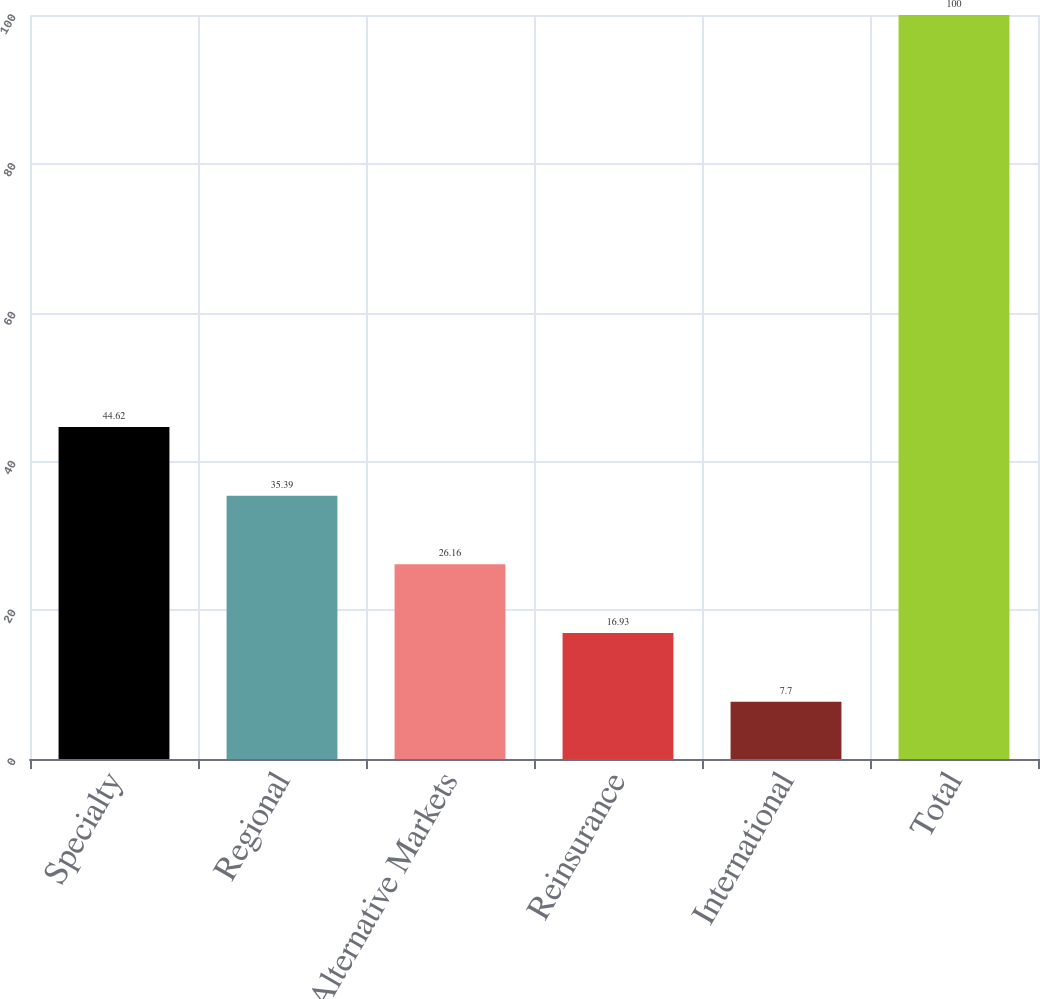Convert chart. <chart><loc_0><loc_0><loc_500><loc_500><bar_chart><fcel>Specialty<fcel>Regional<fcel>Alternative Markets<fcel>Reinsurance<fcel>International<fcel>Total<nl><fcel>44.62<fcel>35.39<fcel>26.16<fcel>16.93<fcel>7.7<fcel>100<nl></chart> 